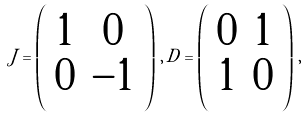<formula> <loc_0><loc_0><loc_500><loc_500>J = \left ( \begin{array} { c c } 1 & 0 \\ 0 & - 1 \end{array} \right ) \, , \, D = \left ( \begin{array} { c c } 0 & 1 \\ 1 & 0 \end{array} \right ) \, ,</formula> 